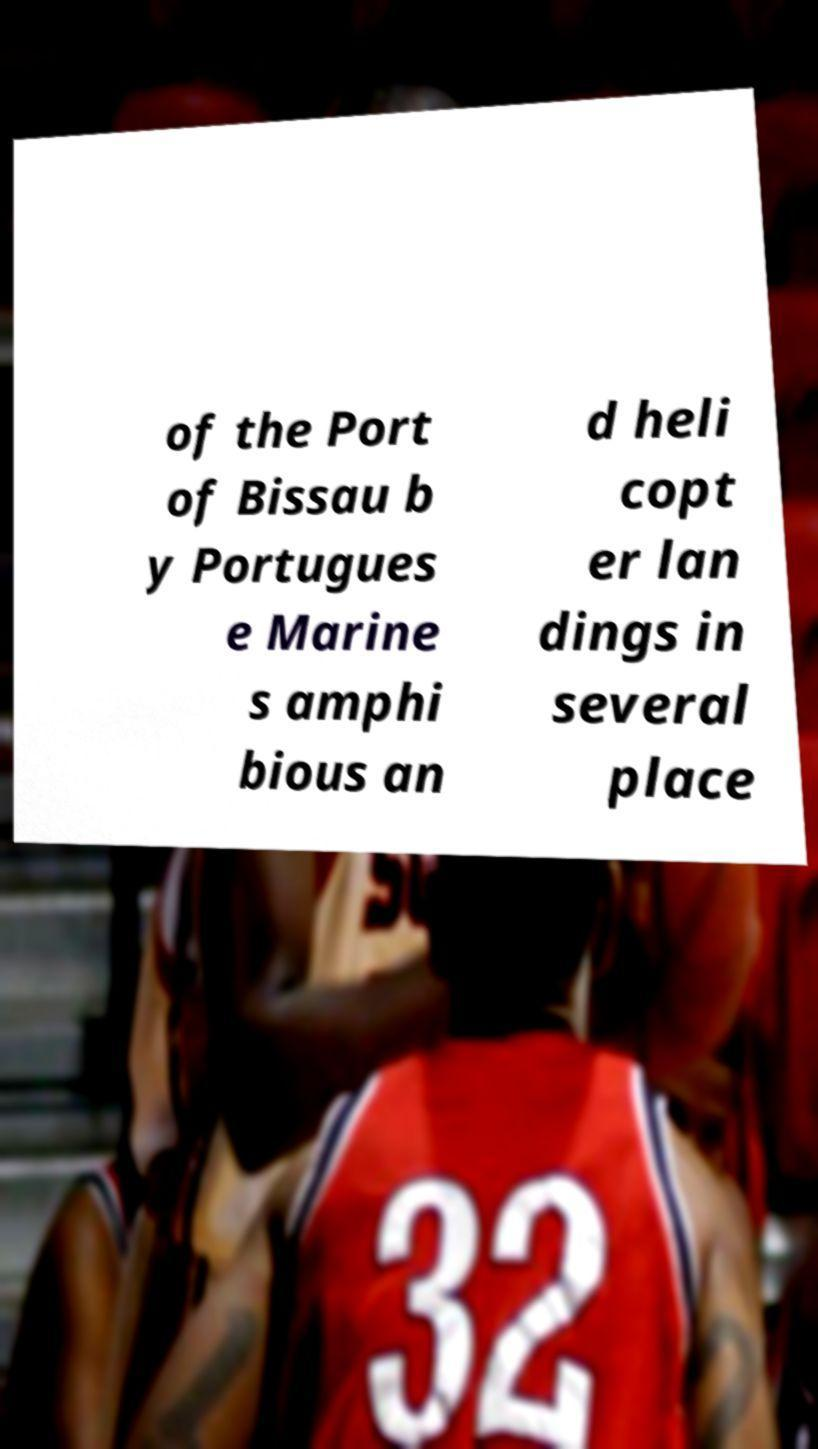Can you read and provide the text displayed in the image?This photo seems to have some interesting text. Can you extract and type it out for me? of the Port of Bissau b y Portugues e Marine s amphi bious an d heli copt er lan dings in several place 